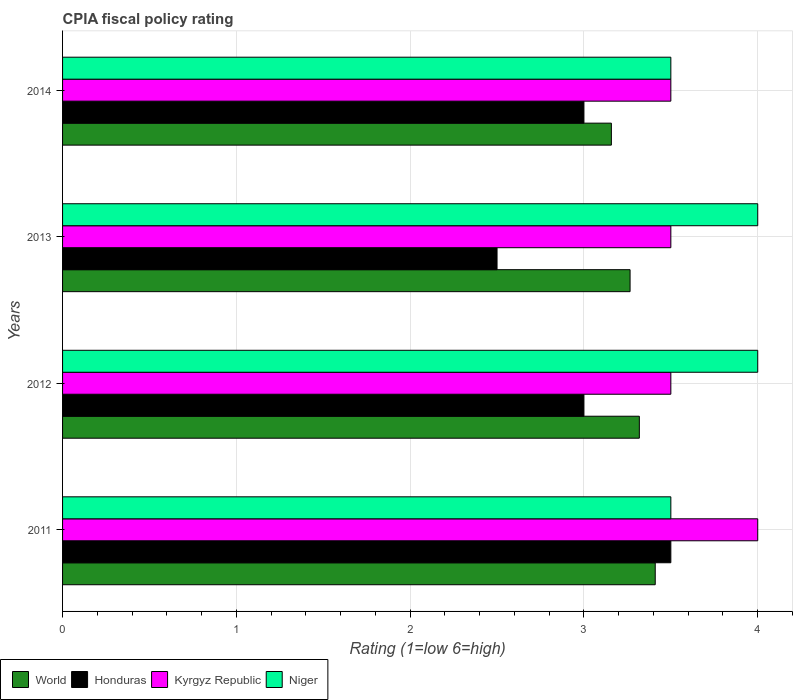How many groups of bars are there?
Offer a very short reply. 4. Are the number of bars on each tick of the Y-axis equal?
Your answer should be compact. Yes. How many bars are there on the 1st tick from the top?
Give a very brief answer. 4. How many bars are there on the 1st tick from the bottom?
Your answer should be very brief. 4. What is the label of the 2nd group of bars from the top?
Provide a succinct answer. 2013. What is the CPIA rating in Honduras in 2013?
Give a very brief answer. 2.5. Across all years, what is the maximum CPIA rating in Honduras?
Offer a terse response. 3.5. Across all years, what is the minimum CPIA rating in World?
Your answer should be very brief. 3.16. In which year was the CPIA rating in World minimum?
Provide a succinct answer. 2014. What is the difference between the CPIA rating in Kyrgyz Republic in 2011 and that in 2014?
Keep it short and to the point. 0.5. What is the difference between the CPIA rating in Kyrgyz Republic in 2014 and the CPIA rating in Niger in 2013?
Provide a succinct answer. -0.5. What is the average CPIA rating in Honduras per year?
Keep it short and to the point. 3. In the year 2012, what is the difference between the CPIA rating in Kyrgyz Republic and CPIA rating in World?
Keep it short and to the point. 0.18. In how many years, is the CPIA rating in Honduras greater than 0.4 ?
Your answer should be compact. 4. What is the ratio of the CPIA rating in Honduras in 2012 to that in 2013?
Make the answer very short. 1.2. Is the CPIA rating in Kyrgyz Republic in 2012 less than that in 2013?
Offer a terse response. No. Is the difference between the CPIA rating in Kyrgyz Republic in 2011 and 2013 greater than the difference between the CPIA rating in World in 2011 and 2013?
Your answer should be compact. Yes. What is the difference between the highest and the second highest CPIA rating in Niger?
Provide a succinct answer. 0. Is the sum of the CPIA rating in World in 2013 and 2014 greater than the maximum CPIA rating in Honduras across all years?
Your answer should be very brief. Yes. What does the 1st bar from the top in 2014 represents?
Ensure brevity in your answer.  Niger. What does the 3rd bar from the bottom in 2011 represents?
Your answer should be compact. Kyrgyz Republic. Is it the case that in every year, the sum of the CPIA rating in Honduras and CPIA rating in Kyrgyz Republic is greater than the CPIA rating in World?
Ensure brevity in your answer.  Yes. Are all the bars in the graph horizontal?
Ensure brevity in your answer.  Yes. How many years are there in the graph?
Your answer should be very brief. 4. What is the difference between two consecutive major ticks on the X-axis?
Provide a short and direct response. 1. Does the graph contain any zero values?
Give a very brief answer. No. Where does the legend appear in the graph?
Give a very brief answer. Bottom left. How many legend labels are there?
Your answer should be compact. 4. How are the legend labels stacked?
Make the answer very short. Horizontal. What is the title of the graph?
Your response must be concise. CPIA fiscal policy rating. Does "Kiribati" appear as one of the legend labels in the graph?
Give a very brief answer. No. What is the label or title of the X-axis?
Provide a succinct answer. Rating (1=low 6=high). What is the label or title of the Y-axis?
Make the answer very short. Years. What is the Rating (1=low 6=high) in World in 2011?
Offer a terse response. 3.41. What is the Rating (1=low 6=high) in Niger in 2011?
Your response must be concise. 3.5. What is the Rating (1=low 6=high) of World in 2012?
Your answer should be very brief. 3.32. What is the Rating (1=low 6=high) of Honduras in 2012?
Your answer should be compact. 3. What is the Rating (1=low 6=high) of Niger in 2012?
Your answer should be very brief. 4. What is the Rating (1=low 6=high) of World in 2013?
Make the answer very short. 3.27. What is the Rating (1=low 6=high) of Honduras in 2013?
Ensure brevity in your answer.  2.5. What is the Rating (1=low 6=high) of World in 2014?
Your response must be concise. 3.16. What is the Rating (1=low 6=high) of Honduras in 2014?
Make the answer very short. 3. What is the Rating (1=low 6=high) in Niger in 2014?
Offer a terse response. 3.5. Across all years, what is the maximum Rating (1=low 6=high) of World?
Make the answer very short. 3.41. Across all years, what is the maximum Rating (1=low 6=high) of Honduras?
Keep it short and to the point. 3.5. Across all years, what is the maximum Rating (1=low 6=high) in Kyrgyz Republic?
Keep it short and to the point. 4. Across all years, what is the minimum Rating (1=low 6=high) in World?
Offer a very short reply. 3.16. Across all years, what is the minimum Rating (1=low 6=high) in Honduras?
Your response must be concise. 2.5. Across all years, what is the minimum Rating (1=low 6=high) in Niger?
Your answer should be compact. 3.5. What is the total Rating (1=low 6=high) of World in the graph?
Offer a very short reply. 13.15. What is the total Rating (1=low 6=high) of Honduras in the graph?
Keep it short and to the point. 12. What is the difference between the Rating (1=low 6=high) in World in 2011 and that in 2012?
Your answer should be compact. 0.09. What is the difference between the Rating (1=low 6=high) of Kyrgyz Republic in 2011 and that in 2012?
Offer a very short reply. 0.5. What is the difference between the Rating (1=low 6=high) in Niger in 2011 and that in 2012?
Your answer should be compact. -0.5. What is the difference between the Rating (1=low 6=high) of World in 2011 and that in 2013?
Give a very brief answer. 0.14. What is the difference between the Rating (1=low 6=high) of World in 2011 and that in 2014?
Your answer should be very brief. 0.25. What is the difference between the Rating (1=low 6=high) of Honduras in 2011 and that in 2014?
Provide a succinct answer. 0.5. What is the difference between the Rating (1=low 6=high) of Kyrgyz Republic in 2011 and that in 2014?
Make the answer very short. 0.5. What is the difference between the Rating (1=low 6=high) in Niger in 2011 and that in 2014?
Offer a terse response. 0. What is the difference between the Rating (1=low 6=high) in World in 2012 and that in 2013?
Your response must be concise. 0.05. What is the difference between the Rating (1=low 6=high) in Honduras in 2012 and that in 2013?
Your response must be concise. 0.5. What is the difference between the Rating (1=low 6=high) of Niger in 2012 and that in 2013?
Offer a terse response. 0. What is the difference between the Rating (1=low 6=high) of World in 2012 and that in 2014?
Ensure brevity in your answer.  0.16. What is the difference between the Rating (1=low 6=high) of Honduras in 2012 and that in 2014?
Offer a terse response. 0. What is the difference between the Rating (1=low 6=high) of Niger in 2012 and that in 2014?
Make the answer very short. 0.5. What is the difference between the Rating (1=low 6=high) of World in 2013 and that in 2014?
Ensure brevity in your answer.  0.11. What is the difference between the Rating (1=low 6=high) of Honduras in 2013 and that in 2014?
Provide a succinct answer. -0.5. What is the difference between the Rating (1=low 6=high) of Kyrgyz Republic in 2013 and that in 2014?
Give a very brief answer. 0. What is the difference between the Rating (1=low 6=high) of World in 2011 and the Rating (1=low 6=high) of Honduras in 2012?
Make the answer very short. 0.41. What is the difference between the Rating (1=low 6=high) of World in 2011 and the Rating (1=low 6=high) of Kyrgyz Republic in 2012?
Give a very brief answer. -0.09. What is the difference between the Rating (1=low 6=high) in World in 2011 and the Rating (1=low 6=high) in Niger in 2012?
Your response must be concise. -0.59. What is the difference between the Rating (1=low 6=high) in Honduras in 2011 and the Rating (1=low 6=high) in Kyrgyz Republic in 2012?
Provide a succinct answer. 0. What is the difference between the Rating (1=low 6=high) of Honduras in 2011 and the Rating (1=low 6=high) of Niger in 2012?
Provide a short and direct response. -0.5. What is the difference between the Rating (1=low 6=high) of World in 2011 and the Rating (1=low 6=high) of Honduras in 2013?
Offer a very short reply. 0.91. What is the difference between the Rating (1=low 6=high) in World in 2011 and the Rating (1=low 6=high) in Kyrgyz Republic in 2013?
Make the answer very short. -0.09. What is the difference between the Rating (1=low 6=high) in World in 2011 and the Rating (1=low 6=high) in Niger in 2013?
Your answer should be compact. -0.59. What is the difference between the Rating (1=low 6=high) in Honduras in 2011 and the Rating (1=low 6=high) in Niger in 2013?
Offer a very short reply. -0.5. What is the difference between the Rating (1=low 6=high) of World in 2011 and the Rating (1=low 6=high) of Honduras in 2014?
Your response must be concise. 0.41. What is the difference between the Rating (1=low 6=high) in World in 2011 and the Rating (1=low 6=high) in Kyrgyz Republic in 2014?
Provide a succinct answer. -0.09. What is the difference between the Rating (1=low 6=high) in World in 2011 and the Rating (1=low 6=high) in Niger in 2014?
Your answer should be compact. -0.09. What is the difference between the Rating (1=low 6=high) of Kyrgyz Republic in 2011 and the Rating (1=low 6=high) of Niger in 2014?
Give a very brief answer. 0.5. What is the difference between the Rating (1=low 6=high) in World in 2012 and the Rating (1=low 6=high) in Honduras in 2013?
Your answer should be compact. 0.82. What is the difference between the Rating (1=low 6=high) of World in 2012 and the Rating (1=low 6=high) of Kyrgyz Republic in 2013?
Ensure brevity in your answer.  -0.18. What is the difference between the Rating (1=low 6=high) of World in 2012 and the Rating (1=low 6=high) of Niger in 2013?
Offer a very short reply. -0.68. What is the difference between the Rating (1=low 6=high) of World in 2012 and the Rating (1=low 6=high) of Honduras in 2014?
Your answer should be compact. 0.32. What is the difference between the Rating (1=low 6=high) of World in 2012 and the Rating (1=low 6=high) of Kyrgyz Republic in 2014?
Keep it short and to the point. -0.18. What is the difference between the Rating (1=low 6=high) of World in 2012 and the Rating (1=low 6=high) of Niger in 2014?
Make the answer very short. -0.18. What is the difference between the Rating (1=low 6=high) in World in 2013 and the Rating (1=low 6=high) in Honduras in 2014?
Your answer should be compact. 0.27. What is the difference between the Rating (1=low 6=high) in World in 2013 and the Rating (1=low 6=high) in Kyrgyz Republic in 2014?
Provide a short and direct response. -0.23. What is the difference between the Rating (1=low 6=high) in World in 2013 and the Rating (1=low 6=high) in Niger in 2014?
Keep it short and to the point. -0.23. What is the difference between the Rating (1=low 6=high) in Honduras in 2013 and the Rating (1=low 6=high) in Kyrgyz Republic in 2014?
Keep it short and to the point. -1. What is the difference between the Rating (1=low 6=high) of Honduras in 2013 and the Rating (1=low 6=high) of Niger in 2014?
Provide a succinct answer. -1. What is the difference between the Rating (1=low 6=high) of Kyrgyz Republic in 2013 and the Rating (1=low 6=high) of Niger in 2014?
Keep it short and to the point. 0. What is the average Rating (1=low 6=high) of World per year?
Your answer should be compact. 3.29. What is the average Rating (1=low 6=high) in Kyrgyz Republic per year?
Offer a terse response. 3.62. What is the average Rating (1=low 6=high) of Niger per year?
Your answer should be very brief. 3.75. In the year 2011, what is the difference between the Rating (1=low 6=high) of World and Rating (1=low 6=high) of Honduras?
Give a very brief answer. -0.09. In the year 2011, what is the difference between the Rating (1=low 6=high) of World and Rating (1=low 6=high) of Kyrgyz Republic?
Offer a terse response. -0.59. In the year 2011, what is the difference between the Rating (1=low 6=high) in World and Rating (1=low 6=high) in Niger?
Offer a terse response. -0.09. In the year 2012, what is the difference between the Rating (1=low 6=high) of World and Rating (1=low 6=high) of Honduras?
Your answer should be very brief. 0.32. In the year 2012, what is the difference between the Rating (1=low 6=high) of World and Rating (1=low 6=high) of Kyrgyz Republic?
Make the answer very short. -0.18. In the year 2012, what is the difference between the Rating (1=low 6=high) of World and Rating (1=low 6=high) of Niger?
Offer a very short reply. -0.68. In the year 2012, what is the difference between the Rating (1=low 6=high) of Honduras and Rating (1=low 6=high) of Kyrgyz Republic?
Offer a very short reply. -0.5. In the year 2013, what is the difference between the Rating (1=low 6=high) of World and Rating (1=low 6=high) of Honduras?
Offer a terse response. 0.77. In the year 2013, what is the difference between the Rating (1=low 6=high) of World and Rating (1=low 6=high) of Kyrgyz Republic?
Offer a terse response. -0.23. In the year 2013, what is the difference between the Rating (1=low 6=high) in World and Rating (1=low 6=high) in Niger?
Your answer should be very brief. -0.73. In the year 2013, what is the difference between the Rating (1=low 6=high) of Kyrgyz Republic and Rating (1=low 6=high) of Niger?
Make the answer very short. -0.5. In the year 2014, what is the difference between the Rating (1=low 6=high) in World and Rating (1=low 6=high) in Honduras?
Give a very brief answer. 0.16. In the year 2014, what is the difference between the Rating (1=low 6=high) of World and Rating (1=low 6=high) of Kyrgyz Republic?
Keep it short and to the point. -0.34. In the year 2014, what is the difference between the Rating (1=low 6=high) in World and Rating (1=low 6=high) in Niger?
Offer a very short reply. -0.34. In the year 2014, what is the difference between the Rating (1=low 6=high) of Honduras and Rating (1=low 6=high) of Kyrgyz Republic?
Make the answer very short. -0.5. In the year 2014, what is the difference between the Rating (1=low 6=high) in Honduras and Rating (1=low 6=high) in Niger?
Ensure brevity in your answer.  -0.5. In the year 2014, what is the difference between the Rating (1=low 6=high) in Kyrgyz Republic and Rating (1=low 6=high) in Niger?
Give a very brief answer. 0. What is the ratio of the Rating (1=low 6=high) in World in 2011 to that in 2012?
Offer a terse response. 1.03. What is the ratio of the Rating (1=low 6=high) of Honduras in 2011 to that in 2012?
Make the answer very short. 1.17. What is the ratio of the Rating (1=low 6=high) in World in 2011 to that in 2013?
Give a very brief answer. 1.04. What is the ratio of the Rating (1=low 6=high) of Honduras in 2011 to that in 2013?
Ensure brevity in your answer.  1.4. What is the ratio of the Rating (1=low 6=high) in World in 2011 to that in 2014?
Offer a terse response. 1.08. What is the ratio of the Rating (1=low 6=high) of Honduras in 2011 to that in 2014?
Provide a short and direct response. 1.17. What is the ratio of the Rating (1=low 6=high) in Kyrgyz Republic in 2011 to that in 2014?
Your answer should be compact. 1.14. What is the ratio of the Rating (1=low 6=high) of World in 2012 to that in 2013?
Offer a very short reply. 1.02. What is the ratio of the Rating (1=low 6=high) in Kyrgyz Republic in 2012 to that in 2013?
Ensure brevity in your answer.  1. What is the ratio of the Rating (1=low 6=high) of Niger in 2012 to that in 2013?
Give a very brief answer. 1. What is the ratio of the Rating (1=low 6=high) in World in 2012 to that in 2014?
Your answer should be compact. 1.05. What is the ratio of the Rating (1=low 6=high) in Niger in 2012 to that in 2014?
Ensure brevity in your answer.  1.14. What is the ratio of the Rating (1=low 6=high) in World in 2013 to that in 2014?
Offer a terse response. 1.03. What is the ratio of the Rating (1=low 6=high) in Niger in 2013 to that in 2014?
Your answer should be compact. 1.14. What is the difference between the highest and the second highest Rating (1=low 6=high) of World?
Offer a terse response. 0.09. What is the difference between the highest and the second highest Rating (1=low 6=high) of Niger?
Provide a succinct answer. 0. What is the difference between the highest and the lowest Rating (1=low 6=high) of World?
Offer a very short reply. 0.25. What is the difference between the highest and the lowest Rating (1=low 6=high) in Niger?
Ensure brevity in your answer.  0.5. 